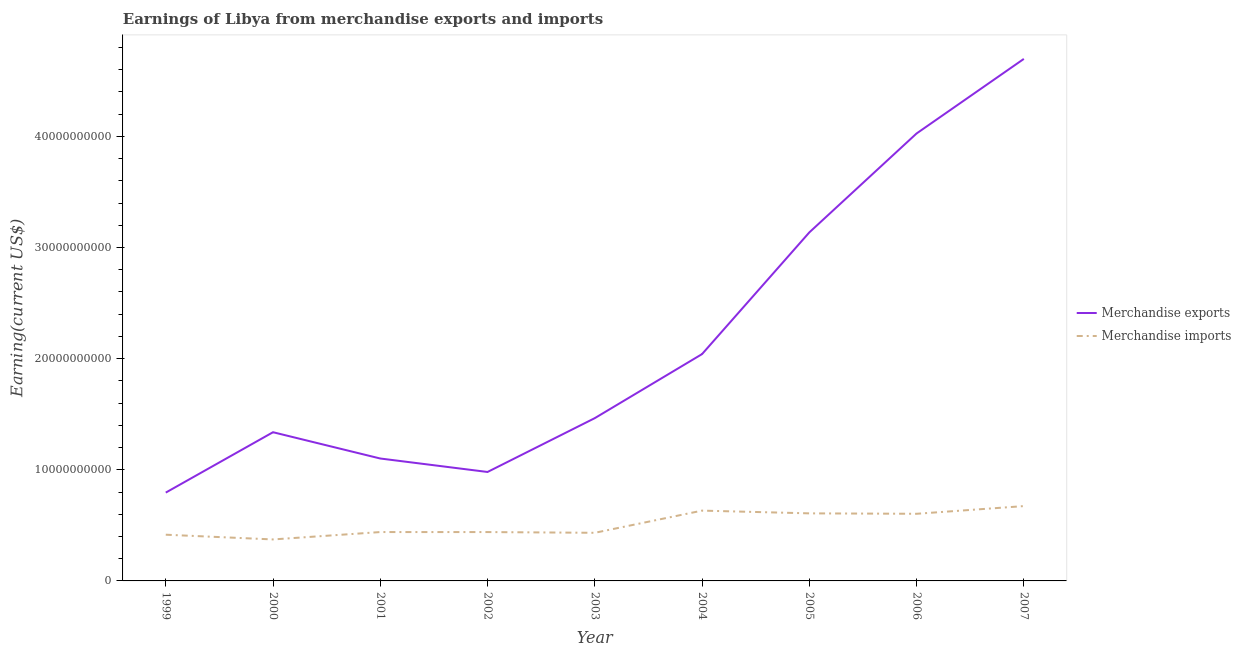Does the line corresponding to earnings from merchandise imports intersect with the line corresponding to earnings from merchandise exports?
Your response must be concise. No. Is the number of lines equal to the number of legend labels?
Keep it short and to the point. Yes. What is the earnings from merchandise imports in 2000?
Provide a short and direct response. 3.73e+09. Across all years, what is the maximum earnings from merchandise imports?
Provide a succinct answer. 6.73e+09. Across all years, what is the minimum earnings from merchandise exports?
Provide a succinct answer. 7.95e+09. In which year was the earnings from merchandise exports maximum?
Your response must be concise. 2007. In which year was the earnings from merchandise imports minimum?
Keep it short and to the point. 2000. What is the total earnings from merchandise exports in the graph?
Make the answer very short. 1.96e+11. What is the difference between the earnings from merchandise imports in 2004 and that in 2006?
Make the answer very short. 2.85e+08. What is the difference between the earnings from merchandise exports in 2007 and the earnings from merchandise imports in 2001?
Provide a short and direct response. 4.26e+1. What is the average earnings from merchandise exports per year?
Your response must be concise. 2.18e+1. In the year 2006, what is the difference between the earnings from merchandise imports and earnings from merchandise exports?
Keep it short and to the point. -3.42e+1. What is the ratio of the earnings from merchandise exports in 2000 to that in 2004?
Provide a succinct answer. 0.66. Is the difference between the earnings from merchandise exports in 2000 and 2007 greater than the difference between the earnings from merchandise imports in 2000 and 2007?
Your answer should be compact. No. What is the difference between the highest and the second highest earnings from merchandise imports?
Your response must be concise. 4.07e+08. What is the difference between the highest and the lowest earnings from merchandise exports?
Offer a terse response. 3.90e+1. Is the sum of the earnings from merchandise exports in 1999 and 2007 greater than the maximum earnings from merchandise imports across all years?
Ensure brevity in your answer.  Yes. Is the earnings from merchandise imports strictly greater than the earnings from merchandise exports over the years?
Offer a terse response. No. Is the earnings from merchandise imports strictly less than the earnings from merchandise exports over the years?
Give a very brief answer. Yes. How many lines are there?
Provide a succinct answer. 2. How many years are there in the graph?
Your response must be concise. 9. What is the difference between two consecutive major ticks on the Y-axis?
Provide a short and direct response. 1.00e+1. Are the values on the major ticks of Y-axis written in scientific E-notation?
Provide a short and direct response. No. Does the graph contain any zero values?
Keep it short and to the point. No. Does the graph contain grids?
Ensure brevity in your answer.  No. Where does the legend appear in the graph?
Your response must be concise. Center right. How many legend labels are there?
Your answer should be very brief. 2. What is the title of the graph?
Your response must be concise. Earnings of Libya from merchandise exports and imports. Does "DAC donors" appear as one of the legend labels in the graph?
Your answer should be very brief. No. What is the label or title of the Y-axis?
Offer a very short reply. Earning(current US$). What is the Earning(current US$) of Merchandise exports in 1999?
Provide a short and direct response. 7.95e+09. What is the Earning(current US$) in Merchandise imports in 1999?
Your response must be concise. 4.16e+09. What is the Earning(current US$) in Merchandise exports in 2000?
Give a very brief answer. 1.34e+1. What is the Earning(current US$) in Merchandise imports in 2000?
Your answer should be compact. 3.73e+09. What is the Earning(current US$) in Merchandise exports in 2001?
Your response must be concise. 1.10e+1. What is the Earning(current US$) of Merchandise imports in 2001?
Ensure brevity in your answer.  4.40e+09. What is the Earning(current US$) of Merchandise exports in 2002?
Ensure brevity in your answer.  9.80e+09. What is the Earning(current US$) in Merchandise imports in 2002?
Give a very brief answer. 4.40e+09. What is the Earning(current US$) of Merchandise exports in 2003?
Offer a terse response. 1.46e+1. What is the Earning(current US$) in Merchandise imports in 2003?
Give a very brief answer. 4.33e+09. What is the Earning(current US$) in Merchandise exports in 2004?
Ensure brevity in your answer.  2.04e+1. What is the Earning(current US$) of Merchandise imports in 2004?
Give a very brief answer. 6.33e+09. What is the Earning(current US$) of Merchandise exports in 2005?
Your response must be concise. 3.14e+1. What is the Earning(current US$) of Merchandise imports in 2005?
Your response must be concise. 6.08e+09. What is the Earning(current US$) of Merchandise exports in 2006?
Your answer should be compact. 4.03e+1. What is the Earning(current US$) in Merchandise imports in 2006?
Provide a succinct answer. 6.04e+09. What is the Earning(current US$) in Merchandise exports in 2007?
Provide a short and direct response. 4.70e+1. What is the Earning(current US$) in Merchandise imports in 2007?
Offer a terse response. 6.73e+09. Across all years, what is the maximum Earning(current US$) of Merchandise exports?
Provide a short and direct response. 4.70e+1. Across all years, what is the maximum Earning(current US$) in Merchandise imports?
Your answer should be compact. 6.73e+09. Across all years, what is the minimum Earning(current US$) of Merchandise exports?
Your response must be concise. 7.95e+09. Across all years, what is the minimum Earning(current US$) in Merchandise imports?
Ensure brevity in your answer.  3.73e+09. What is the total Earning(current US$) in Merchandise exports in the graph?
Your response must be concise. 1.96e+11. What is the total Earning(current US$) in Merchandise imports in the graph?
Make the answer very short. 4.62e+1. What is the difference between the Earning(current US$) of Merchandise exports in 1999 and that in 2000?
Ensure brevity in your answer.  -5.43e+09. What is the difference between the Earning(current US$) of Merchandise imports in 1999 and that in 2000?
Make the answer very short. 4.26e+08. What is the difference between the Earning(current US$) of Merchandise exports in 1999 and that in 2001?
Make the answer very short. -3.07e+09. What is the difference between the Earning(current US$) in Merchandise imports in 1999 and that in 2001?
Make the answer very short. -2.39e+08. What is the difference between the Earning(current US$) of Merchandise exports in 1999 and that in 2002?
Make the answer very short. -1.86e+09. What is the difference between the Earning(current US$) of Merchandise imports in 1999 and that in 2002?
Ensure brevity in your answer.  -2.38e+08. What is the difference between the Earning(current US$) in Merchandise exports in 1999 and that in 2003?
Give a very brief answer. -6.70e+09. What is the difference between the Earning(current US$) in Merchandise imports in 1999 and that in 2003?
Ensure brevity in your answer.  -1.72e+08. What is the difference between the Earning(current US$) of Merchandise exports in 1999 and that in 2004?
Ensure brevity in your answer.  -1.25e+1. What is the difference between the Earning(current US$) of Merchandise imports in 1999 and that in 2004?
Your answer should be compact. -2.17e+09. What is the difference between the Earning(current US$) in Merchandise exports in 1999 and that in 2005?
Your response must be concise. -2.34e+1. What is the difference between the Earning(current US$) of Merchandise imports in 1999 and that in 2005?
Your answer should be compact. -1.92e+09. What is the difference between the Earning(current US$) in Merchandise exports in 1999 and that in 2006?
Your answer should be very brief. -3.23e+1. What is the difference between the Earning(current US$) in Merchandise imports in 1999 and that in 2006?
Ensure brevity in your answer.  -1.88e+09. What is the difference between the Earning(current US$) in Merchandise exports in 1999 and that in 2007?
Make the answer very short. -3.90e+1. What is the difference between the Earning(current US$) in Merchandise imports in 1999 and that in 2007?
Offer a very short reply. -2.58e+09. What is the difference between the Earning(current US$) of Merchandise exports in 2000 and that in 2001?
Offer a terse response. 2.37e+09. What is the difference between the Earning(current US$) in Merchandise imports in 2000 and that in 2001?
Your answer should be compact. -6.65e+08. What is the difference between the Earning(current US$) of Merchandise exports in 2000 and that in 2002?
Ensure brevity in your answer.  3.58e+09. What is the difference between the Earning(current US$) of Merchandise imports in 2000 and that in 2002?
Your answer should be very brief. -6.64e+08. What is the difference between the Earning(current US$) in Merchandise exports in 2000 and that in 2003?
Give a very brief answer. -1.27e+09. What is the difference between the Earning(current US$) of Merchandise imports in 2000 and that in 2003?
Make the answer very short. -5.98e+08. What is the difference between the Earning(current US$) in Merchandise exports in 2000 and that in 2004?
Make the answer very short. -7.03e+09. What is the difference between the Earning(current US$) in Merchandise imports in 2000 and that in 2004?
Your response must be concise. -2.59e+09. What is the difference between the Earning(current US$) in Merchandise exports in 2000 and that in 2005?
Your response must be concise. -1.80e+1. What is the difference between the Earning(current US$) in Merchandise imports in 2000 and that in 2005?
Your response must be concise. -2.35e+09. What is the difference between the Earning(current US$) in Merchandise exports in 2000 and that in 2006?
Give a very brief answer. -2.69e+1. What is the difference between the Earning(current US$) of Merchandise imports in 2000 and that in 2006?
Make the answer very short. -2.31e+09. What is the difference between the Earning(current US$) in Merchandise exports in 2000 and that in 2007?
Offer a terse response. -3.36e+1. What is the difference between the Earning(current US$) in Merchandise imports in 2000 and that in 2007?
Give a very brief answer. -3.00e+09. What is the difference between the Earning(current US$) of Merchandise exports in 2001 and that in 2002?
Offer a terse response. 1.21e+09. What is the difference between the Earning(current US$) of Merchandise exports in 2001 and that in 2003?
Your response must be concise. -3.63e+09. What is the difference between the Earning(current US$) in Merchandise imports in 2001 and that in 2003?
Provide a short and direct response. 6.70e+07. What is the difference between the Earning(current US$) in Merchandise exports in 2001 and that in 2004?
Ensure brevity in your answer.  -9.40e+09. What is the difference between the Earning(current US$) in Merchandise imports in 2001 and that in 2004?
Your answer should be very brief. -1.93e+09. What is the difference between the Earning(current US$) of Merchandise exports in 2001 and that in 2005?
Your response must be concise. -2.03e+1. What is the difference between the Earning(current US$) in Merchandise imports in 2001 and that in 2005?
Make the answer very short. -1.68e+09. What is the difference between the Earning(current US$) of Merchandise exports in 2001 and that in 2006?
Give a very brief answer. -2.92e+1. What is the difference between the Earning(current US$) of Merchandise imports in 2001 and that in 2006?
Make the answer very short. -1.64e+09. What is the difference between the Earning(current US$) in Merchandise exports in 2001 and that in 2007?
Keep it short and to the point. -3.60e+1. What is the difference between the Earning(current US$) of Merchandise imports in 2001 and that in 2007?
Ensure brevity in your answer.  -2.34e+09. What is the difference between the Earning(current US$) in Merchandise exports in 2002 and that in 2003?
Make the answer very short. -4.84e+09. What is the difference between the Earning(current US$) in Merchandise imports in 2002 and that in 2003?
Provide a short and direct response. 6.60e+07. What is the difference between the Earning(current US$) in Merchandise exports in 2002 and that in 2004?
Provide a succinct answer. -1.06e+1. What is the difference between the Earning(current US$) of Merchandise imports in 2002 and that in 2004?
Provide a succinct answer. -1.93e+09. What is the difference between the Earning(current US$) in Merchandise exports in 2002 and that in 2005?
Your answer should be compact. -2.16e+1. What is the difference between the Earning(current US$) of Merchandise imports in 2002 and that in 2005?
Ensure brevity in your answer.  -1.68e+09. What is the difference between the Earning(current US$) in Merchandise exports in 2002 and that in 2006?
Provide a succinct answer. -3.05e+1. What is the difference between the Earning(current US$) in Merchandise imports in 2002 and that in 2006?
Provide a succinct answer. -1.64e+09. What is the difference between the Earning(current US$) of Merchandise exports in 2002 and that in 2007?
Keep it short and to the point. -3.72e+1. What is the difference between the Earning(current US$) of Merchandise imports in 2002 and that in 2007?
Give a very brief answer. -2.34e+09. What is the difference between the Earning(current US$) in Merchandise exports in 2003 and that in 2004?
Your response must be concise. -5.76e+09. What is the difference between the Earning(current US$) of Merchandise imports in 2003 and that in 2004?
Provide a succinct answer. -2.00e+09. What is the difference between the Earning(current US$) of Merchandise exports in 2003 and that in 2005?
Make the answer very short. -1.67e+1. What is the difference between the Earning(current US$) in Merchandise imports in 2003 and that in 2005?
Your answer should be very brief. -1.75e+09. What is the difference between the Earning(current US$) in Merchandise exports in 2003 and that in 2006?
Your answer should be very brief. -2.56e+1. What is the difference between the Earning(current US$) in Merchandise imports in 2003 and that in 2006?
Give a very brief answer. -1.71e+09. What is the difference between the Earning(current US$) of Merchandise exports in 2003 and that in 2007?
Your answer should be very brief. -3.23e+1. What is the difference between the Earning(current US$) in Merchandise imports in 2003 and that in 2007?
Provide a short and direct response. -2.40e+09. What is the difference between the Earning(current US$) of Merchandise exports in 2004 and that in 2005?
Your response must be concise. -1.09e+1. What is the difference between the Earning(current US$) in Merchandise imports in 2004 and that in 2005?
Offer a very short reply. 2.47e+08. What is the difference between the Earning(current US$) of Merchandise exports in 2004 and that in 2006?
Offer a terse response. -1.99e+1. What is the difference between the Earning(current US$) in Merchandise imports in 2004 and that in 2006?
Give a very brief answer. 2.85e+08. What is the difference between the Earning(current US$) of Merchandise exports in 2004 and that in 2007?
Make the answer very short. -2.66e+1. What is the difference between the Earning(current US$) of Merchandise imports in 2004 and that in 2007?
Make the answer very short. -4.07e+08. What is the difference between the Earning(current US$) in Merchandise exports in 2005 and that in 2006?
Give a very brief answer. -8.90e+09. What is the difference between the Earning(current US$) of Merchandise imports in 2005 and that in 2006?
Your answer should be very brief. 3.84e+07. What is the difference between the Earning(current US$) in Merchandise exports in 2005 and that in 2007?
Your response must be concise. -1.56e+1. What is the difference between the Earning(current US$) of Merchandise imports in 2005 and that in 2007?
Provide a succinct answer. -6.54e+08. What is the difference between the Earning(current US$) in Merchandise exports in 2006 and that in 2007?
Provide a short and direct response. -6.71e+09. What is the difference between the Earning(current US$) of Merchandise imports in 2006 and that in 2007?
Make the answer very short. -6.92e+08. What is the difference between the Earning(current US$) in Merchandise exports in 1999 and the Earning(current US$) in Merchandise imports in 2000?
Your answer should be very brief. 4.22e+09. What is the difference between the Earning(current US$) of Merchandise exports in 1999 and the Earning(current US$) of Merchandise imports in 2001?
Make the answer very short. 3.55e+09. What is the difference between the Earning(current US$) of Merchandise exports in 1999 and the Earning(current US$) of Merchandise imports in 2002?
Ensure brevity in your answer.  3.55e+09. What is the difference between the Earning(current US$) of Merchandise exports in 1999 and the Earning(current US$) of Merchandise imports in 2003?
Your response must be concise. 3.62e+09. What is the difference between the Earning(current US$) in Merchandise exports in 1999 and the Earning(current US$) in Merchandise imports in 2004?
Keep it short and to the point. 1.62e+09. What is the difference between the Earning(current US$) of Merchandise exports in 1999 and the Earning(current US$) of Merchandise imports in 2005?
Make the answer very short. 1.87e+09. What is the difference between the Earning(current US$) in Merchandise exports in 1999 and the Earning(current US$) in Merchandise imports in 2006?
Your response must be concise. 1.91e+09. What is the difference between the Earning(current US$) of Merchandise exports in 1999 and the Earning(current US$) of Merchandise imports in 2007?
Provide a succinct answer. 1.21e+09. What is the difference between the Earning(current US$) in Merchandise exports in 2000 and the Earning(current US$) in Merchandise imports in 2001?
Ensure brevity in your answer.  8.98e+09. What is the difference between the Earning(current US$) in Merchandise exports in 2000 and the Earning(current US$) in Merchandise imports in 2002?
Your answer should be compact. 8.98e+09. What is the difference between the Earning(current US$) in Merchandise exports in 2000 and the Earning(current US$) in Merchandise imports in 2003?
Your answer should be very brief. 9.05e+09. What is the difference between the Earning(current US$) in Merchandise exports in 2000 and the Earning(current US$) in Merchandise imports in 2004?
Provide a short and direct response. 7.05e+09. What is the difference between the Earning(current US$) in Merchandise exports in 2000 and the Earning(current US$) in Merchandise imports in 2005?
Give a very brief answer. 7.30e+09. What is the difference between the Earning(current US$) of Merchandise exports in 2000 and the Earning(current US$) of Merchandise imports in 2006?
Keep it short and to the point. 7.34e+09. What is the difference between the Earning(current US$) of Merchandise exports in 2000 and the Earning(current US$) of Merchandise imports in 2007?
Offer a terse response. 6.65e+09. What is the difference between the Earning(current US$) of Merchandise exports in 2001 and the Earning(current US$) of Merchandise imports in 2002?
Give a very brief answer. 6.62e+09. What is the difference between the Earning(current US$) of Merchandise exports in 2001 and the Earning(current US$) of Merchandise imports in 2003?
Your answer should be very brief. 6.68e+09. What is the difference between the Earning(current US$) of Merchandise exports in 2001 and the Earning(current US$) of Merchandise imports in 2004?
Your answer should be very brief. 4.69e+09. What is the difference between the Earning(current US$) of Merchandise exports in 2001 and the Earning(current US$) of Merchandise imports in 2005?
Ensure brevity in your answer.  4.94e+09. What is the difference between the Earning(current US$) in Merchandise exports in 2001 and the Earning(current US$) in Merchandise imports in 2006?
Ensure brevity in your answer.  4.97e+09. What is the difference between the Earning(current US$) in Merchandise exports in 2001 and the Earning(current US$) in Merchandise imports in 2007?
Make the answer very short. 4.28e+09. What is the difference between the Earning(current US$) in Merchandise exports in 2002 and the Earning(current US$) in Merchandise imports in 2003?
Make the answer very short. 5.47e+09. What is the difference between the Earning(current US$) in Merchandise exports in 2002 and the Earning(current US$) in Merchandise imports in 2004?
Provide a short and direct response. 3.48e+09. What is the difference between the Earning(current US$) of Merchandise exports in 2002 and the Earning(current US$) of Merchandise imports in 2005?
Offer a very short reply. 3.72e+09. What is the difference between the Earning(current US$) of Merchandise exports in 2002 and the Earning(current US$) of Merchandise imports in 2006?
Offer a very short reply. 3.76e+09. What is the difference between the Earning(current US$) in Merchandise exports in 2002 and the Earning(current US$) in Merchandise imports in 2007?
Ensure brevity in your answer.  3.07e+09. What is the difference between the Earning(current US$) in Merchandise exports in 2003 and the Earning(current US$) in Merchandise imports in 2004?
Provide a short and direct response. 8.32e+09. What is the difference between the Earning(current US$) in Merchandise exports in 2003 and the Earning(current US$) in Merchandise imports in 2005?
Provide a short and direct response. 8.57e+09. What is the difference between the Earning(current US$) of Merchandise exports in 2003 and the Earning(current US$) of Merchandise imports in 2006?
Your answer should be compact. 8.61e+09. What is the difference between the Earning(current US$) in Merchandise exports in 2003 and the Earning(current US$) in Merchandise imports in 2007?
Keep it short and to the point. 7.91e+09. What is the difference between the Earning(current US$) in Merchandise exports in 2004 and the Earning(current US$) in Merchandise imports in 2005?
Your answer should be very brief. 1.43e+1. What is the difference between the Earning(current US$) of Merchandise exports in 2004 and the Earning(current US$) of Merchandise imports in 2006?
Your answer should be compact. 1.44e+1. What is the difference between the Earning(current US$) in Merchandise exports in 2004 and the Earning(current US$) in Merchandise imports in 2007?
Ensure brevity in your answer.  1.37e+1. What is the difference between the Earning(current US$) in Merchandise exports in 2005 and the Earning(current US$) in Merchandise imports in 2006?
Your response must be concise. 2.53e+1. What is the difference between the Earning(current US$) of Merchandise exports in 2005 and the Earning(current US$) of Merchandise imports in 2007?
Make the answer very short. 2.46e+1. What is the difference between the Earning(current US$) of Merchandise exports in 2006 and the Earning(current US$) of Merchandise imports in 2007?
Your answer should be compact. 3.35e+1. What is the average Earning(current US$) of Merchandise exports per year?
Ensure brevity in your answer.  2.18e+1. What is the average Earning(current US$) of Merchandise imports per year?
Offer a very short reply. 5.13e+09. In the year 1999, what is the difference between the Earning(current US$) of Merchandise exports and Earning(current US$) of Merchandise imports?
Your answer should be compact. 3.79e+09. In the year 2000, what is the difference between the Earning(current US$) of Merchandise exports and Earning(current US$) of Merchandise imports?
Your answer should be compact. 9.65e+09. In the year 2001, what is the difference between the Earning(current US$) of Merchandise exports and Earning(current US$) of Merchandise imports?
Offer a terse response. 6.62e+09. In the year 2002, what is the difference between the Earning(current US$) in Merchandise exports and Earning(current US$) in Merchandise imports?
Offer a very short reply. 5.41e+09. In the year 2003, what is the difference between the Earning(current US$) of Merchandise exports and Earning(current US$) of Merchandise imports?
Your response must be concise. 1.03e+1. In the year 2004, what is the difference between the Earning(current US$) in Merchandise exports and Earning(current US$) in Merchandise imports?
Your response must be concise. 1.41e+1. In the year 2005, what is the difference between the Earning(current US$) of Merchandise exports and Earning(current US$) of Merchandise imports?
Provide a succinct answer. 2.53e+1. In the year 2006, what is the difference between the Earning(current US$) in Merchandise exports and Earning(current US$) in Merchandise imports?
Ensure brevity in your answer.  3.42e+1. In the year 2007, what is the difference between the Earning(current US$) in Merchandise exports and Earning(current US$) in Merchandise imports?
Make the answer very short. 4.02e+1. What is the ratio of the Earning(current US$) of Merchandise exports in 1999 to that in 2000?
Offer a very short reply. 0.59. What is the ratio of the Earning(current US$) of Merchandise imports in 1999 to that in 2000?
Offer a terse response. 1.11. What is the ratio of the Earning(current US$) of Merchandise exports in 1999 to that in 2001?
Keep it short and to the point. 0.72. What is the ratio of the Earning(current US$) of Merchandise imports in 1999 to that in 2001?
Give a very brief answer. 0.95. What is the ratio of the Earning(current US$) of Merchandise exports in 1999 to that in 2002?
Offer a terse response. 0.81. What is the ratio of the Earning(current US$) of Merchandise imports in 1999 to that in 2002?
Give a very brief answer. 0.95. What is the ratio of the Earning(current US$) of Merchandise exports in 1999 to that in 2003?
Offer a very short reply. 0.54. What is the ratio of the Earning(current US$) in Merchandise imports in 1999 to that in 2003?
Offer a terse response. 0.96. What is the ratio of the Earning(current US$) of Merchandise exports in 1999 to that in 2004?
Your answer should be compact. 0.39. What is the ratio of the Earning(current US$) of Merchandise imports in 1999 to that in 2004?
Give a very brief answer. 0.66. What is the ratio of the Earning(current US$) of Merchandise exports in 1999 to that in 2005?
Give a very brief answer. 0.25. What is the ratio of the Earning(current US$) of Merchandise imports in 1999 to that in 2005?
Your answer should be compact. 0.68. What is the ratio of the Earning(current US$) of Merchandise exports in 1999 to that in 2006?
Offer a terse response. 0.2. What is the ratio of the Earning(current US$) in Merchandise imports in 1999 to that in 2006?
Ensure brevity in your answer.  0.69. What is the ratio of the Earning(current US$) in Merchandise exports in 1999 to that in 2007?
Offer a very short reply. 0.17. What is the ratio of the Earning(current US$) of Merchandise imports in 1999 to that in 2007?
Your response must be concise. 0.62. What is the ratio of the Earning(current US$) of Merchandise exports in 2000 to that in 2001?
Give a very brief answer. 1.21. What is the ratio of the Earning(current US$) in Merchandise imports in 2000 to that in 2001?
Your answer should be compact. 0.85. What is the ratio of the Earning(current US$) of Merchandise exports in 2000 to that in 2002?
Provide a short and direct response. 1.36. What is the ratio of the Earning(current US$) in Merchandise imports in 2000 to that in 2002?
Make the answer very short. 0.85. What is the ratio of the Earning(current US$) in Merchandise exports in 2000 to that in 2003?
Offer a very short reply. 0.91. What is the ratio of the Earning(current US$) of Merchandise imports in 2000 to that in 2003?
Offer a very short reply. 0.86. What is the ratio of the Earning(current US$) in Merchandise exports in 2000 to that in 2004?
Keep it short and to the point. 0.66. What is the ratio of the Earning(current US$) of Merchandise imports in 2000 to that in 2004?
Offer a terse response. 0.59. What is the ratio of the Earning(current US$) in Merchandise exports in 2000 to that in 2005?
Offer a very short reply. 0.43. What is the ratio of the Earning(current US$) of Merchandise imports in 2000 to that in 2005?
Give a very brief answer. 0.61. What is the ratio of the Earning(current US$) in Merchandise exports in 2000 to that in 2006?
Keep it short and to the point. 0.33. What is the ratio of the Earning(current US$) in Merchandise imports in 2000 to that in 2006?
Your answer should be compact. 0.62. What is the ratio of the Earning(current US$) of Merchandise exports in 2000 to that in 2007?
Keep it short and to the point. 0.28. What is the ratio of the Earning(current US$) in Merchandise imports in 2000 to that in 2007?
Your answer should be very brief. 0.55. What is the ratio of the Earning(current US$) of Merchandise exports in 2001 to that in 2002?
Offer a very short reply. 1.12. What is the ratio of the Earning(current US$) of Merchandise exports in 2001 to that in 2003?
Your response must be concise. 0.75. What is the ratio of the Earning(current US$) in Merchandise imports in 2001 to that in 2003?
Offer a terse response. 1.02. What is the ratio of the Earning(current US$) of Merchandise exports in 2001 to that in 2004?
Provide a succinct answer. 0.54. What is the ratio of the Earning(current US$) in Merchandise imports in 2001 to that in 2004?
Your answer should be very brief. 0.7. What is the ratio of the Earning(current US$) of Merchandise exports in 2001 to that in 2005?
Your response must be concise. 0.35. What is the ratio of the Earning(current US$) of Merchandise imports in 2001 to that in 2005?
Make the answer very short. 0.72. What is the ratio of the Earning(current US$) in Merchandise exports in 2001 to that in 2006?
Your response must be concise. 0.27. What is the ratio of the Earning(current US$) in Merchandise imports in 2001 to that in 2006?
Provide a succinct answer. 0.73. What is the ratio of the Earning(current US$) in Merchandise exports in 2001 to that in 2007?
Offer a terse response. 0.23. What is the ratio of the Earning(current US$) in Merchandise imports in 2001 to that in 2007?
Keep it short and to the point. 0.65. What is the ratio of the Earning(current US$) of Merchandise exports in 2002 to that in 2003?
Provide a short and direct response. 0.67. What is the ratio of the Earning(current US$) in Merchandise imports in 2002 to that in 2003?
Make the answer very short. 1.02. What is the ratio of the Earning(current US$) of Merchandise exports in 2002 to that in 2004?
Your response must be concise. 0.48. What is the ratio of the Earning(current US$) of Merchandise imports in 2002 to that in 2004?
Offer a terse response. 0.69. What is the ratio of the Earning(current US$) of Merchandise exports in 2002 to that in 2005?
Offer a very short reply. 0.31. What is the ratio of the Earning(current US$) of Merchandise imports in 2002 to that in 2005?
Give a very brief answer. 0.72. What is the ratio of the Earning(current US$) in Merchandise exports in 2002 to that in 2006?
Offer a terse response. 0.24. What is the ratio of the Earning(current US$) in Merchandise imports in 2002 to that in 2006?
Give a very brief answer. 0.73. What is the ratio of the Earning(current US$) in Merchandise exports in 2002 to that in 2007?
Give a very brief answer. 0.21. What is the ratio of the Earning(current US$) of Merchandise imports in 2002 to that in 2007?
Ensure brevity in your answer.  0.65. What is the ratio of the Earning(current US$) of Merchandise exports in 2003 to that in 2004?
Ensure brevity in your answer.  0.72. What is the ratio of the Earning(current US$) in Merchandise imports in 2003 to that in 2004?
Offer a very short reply. 0.68. What is the ratio of the Earning(current US$) of Merchandise exports in 2003 to that in 2005?
Keep it short and to the point. 0.47. What is the ratio of the Earning(current US$) of Merchandise imports in 2003 to that in 2005?
Your answer should be very brief. 0.71. What is the ratio of the Earning(current US$) of Merchandise exports in 2003 to that in 2006?
Make the answer very short. 0.36. What is the ratio of the Earning(current US$) of Merchandise imports in 2003 to that in 2006?
Provide a succinct answer. 0.72. What is the ratio of the Earning(current US$) of Merchandise exports in 2003 to that in 2007?
Your answer should be compact. 0.31. What is the ratio of the Earning(current US$) in Merchandise imports in 2003 to that in 2007?
Ensure brevity in your answer.  0.64. What is the ratio of the Earning(current US$) in Merchandise exports in 2004 to that in 2005?
Your response must be concise. 0.65. What is the ratio of the Earning(current US$) of Merchandise imports in 2004 to that in 2005?
Your response must be concise. 1.04. What is the ratio of the Earning(current US$) of Merchandise exports in 2004 to that in 2006?
Offer a very short reply. 0.51. What is the ratio of the Earning(current US$) in Merchandise imports in 2004 to that in 2006?
Offer a very short reply. 1.05. What is the ratio of the Earning(current US$) in Merchandise exports in 2004 to that in 2007?
Ensure brevity in your answer.  0.43. What is the ratio of the Earning(current US$) of Merchandise imports in 2004 to that in 2007?
Provide a succinct answer. 0.94. What is the ratio of the Earning(current US$) in Merchandise exports in 2005 to that in 2006?
Your response must be concise. 0.78. What is the ratio of the Earning(current US$) in Merchandise imports in 2005 to that in 2006?
Ensure brevity in your answer.  1.01. What is the ratio of the Earning(current US$) in Merchandise exports in 2005 to that in 2007?
Keep it short and to the point. 0.67. What is the ratio of the Earning(current US$) of Merchandise imports in 2005 to that in 2007?
Keep it short and to the point. 0.9. What is the ratio of the Earning(current US$) of Merchandise exports in 2006 to that in 2007?
Provide a succinct answer. 0.86. What is the ratio of the Earning(current US$) of Merchandise imports in 2006 to that in 2007?
Keep it short and to the point. 0.9. What is the difference between the highest and the second highest Earning(current US$) in Merchandise exports?
Keep it short and to the point. 6.71e+09. What is the difference between the highest and the second highest Earning(current US$) in Merchandise imports?
Provide a short and direct response. 4.07e+08. What is the difference between the highest and the lowest Earning(current US$) in Merchandise exports?
Offer a very short reply. 3.90e+1. What is the difference between the highest and the lowest Earning(current US$) of Merchandise imports?
Keep it short and to the point. 3.00e+09. 